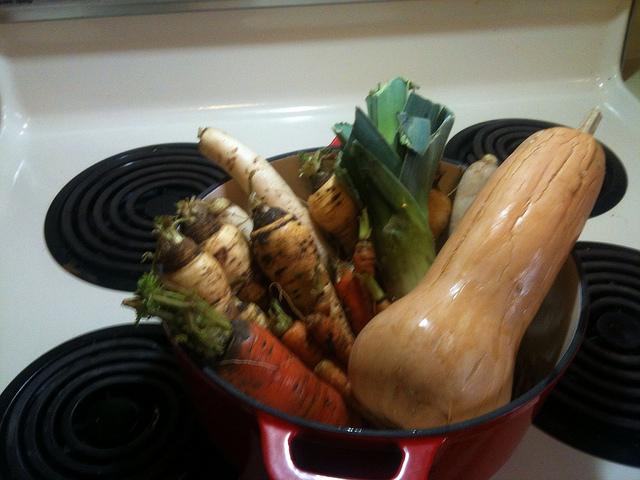How many different types of veggie are in this image?
Be succinct. 4. How many burners are on the stove?
Keep it brief. 4. Is this a gas stove?
Quick response, please. No. What color is the pot?
Quick response, please. Red. 